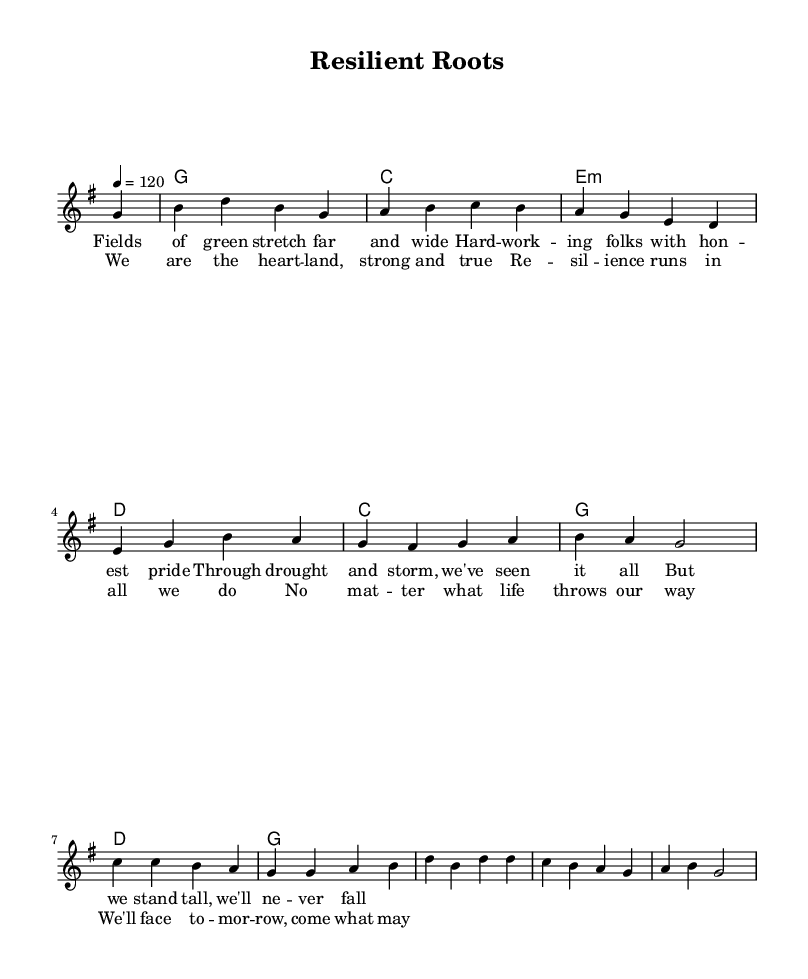What is the key signature of this music? The key signature is G major, which has one sharp (F#) indicated in the beginning of the staff.
Answer: G major What is the time signature of this music? The time signature is 4/4, shown at the beginning of the score with four beats per measure.
Answer: 4/4 What is the tempo marking of this piece? The tempo marking states "4 = 120," indicating a quarter note plays at a speed of 120 beats per minute.
Answer: 120 How many measures are in the chorus? The chorus consists of four measures, as counted from the aligned notes and lyrics in that section of the score.
Answer: Four What is the vocal range indicated by the melody? The melody is written in the relative pitch phrasing from G4 down to E3, indicating a range typically within a tenor range.
Answer: Tenor Which chord is played at the beginning of the verse? The first chord played at the beginning of the verse is G major, as seen in the chord notations aligned with the melody.
Answer: G What theme does the chorus express regarding community? The chorus conveys a theme of resilience, emphasizing the strength and determination of the community in facing challenges, evident in the phrasing and lyrics.
Answer: Resilience 